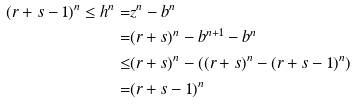<formula> <loc_0><loc_0><loc_500><loc_500>( r + s - 1 ) ^ { n } \leq h ^ { n } = & z ^ { n } - b ^ { n } \\ = & ( r + s ) ^ { n } - b ^ { n + 1 } - b ^ { n } \\ \leq & ( r + s ) ^ { n } - ( ( r + s ) ^ { n } - ( r + s - 1 ) ^ { n } ) \\ = & ( r + s - 1 ) ^ { n }</formula> 